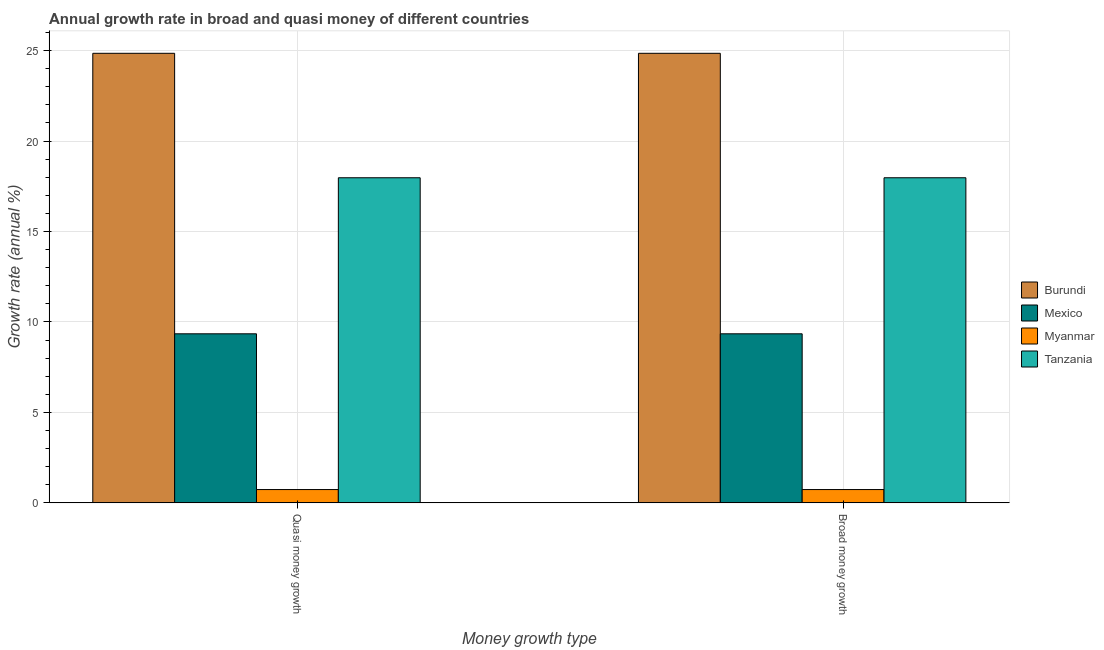How many different coloured bars are there?
Keep it short and to the point. 4. Are the number of bars per tick equal to the number of legend labels?
Keep it short and to the point. Yes. How many bars are there on the 1st tick from the left?
Offer a terse response. 4. What is the label of the 1st group of bars from the left?
Your answer should be compact. Quasi money growth. What is the annual growth rate in broad money in Myanmar?
Your answer should be very brief. 0.73. Across all countries, what is the maximum annual growth rate in quasi money?
Provide a succinct answer. 24.85. Across all countries, what is the minimum annual growth rate in broad money?
Keep it short and to the point. 0.73. In which country was the annual growth rate in quasi money maximum?
Provide a succinct answer. Burundi. In which country was the annual growth rate in quasi money minimum?
Offer a very short reply. Myanmar. What is the total annual growth rate in broad money in the graph?
Your answer should be very brief. 52.89. What is the difference between the annual growth rate in quasi money in Mexico and that in Myanmar?
Offer a terse response. 8.61. What is the difference between the annual growth rate in quasi money in Mexico and the annual growth rate in broad money in Tanzania?
Ensure brevity in your answer.  -8.63. What is the average annual growth rate in broad money per country?
Give a very brief answer. 13.22. What is the difference between the annual growth rate in quasi money and annual growth rate in broad money in Myanmar?
Provide a succinct answer. 0. What is the ratio of the annual growth rate in broad money in Myanmar to that in Tanzania?
Keep it short and to the point. 0.04. What does the 3rd bar from the left in Broad money growth represents?
Provide a short and direct response. Myanmar. What does the 3rd bar from the right in Broad money growth represents?
Keep it short and to the point. Mexico. How many countries are there in the graph?
Provide a short and direct response. 4. What is the difference between two consecutive major ticks on the Y-axis?
Give a very brief answer. 5. Are the values on the major ticks of Y-axis written in scientific E-notation?
Make the answer very short. No. Does the graph contain grids?
Give a very brief answer. Yes. What is the title of the graph?
Your answer should be very brief. Annual growth rate in broad and quasi money of different countries. What is the label or title of the X-axis?
Provide a short and direct response. Money growth type. What is the label or title of the Y-axis?
Provide a succinct answer. Growth rate (annual %). What is the Growth rate (annual %) of Burundi in Quasi money growth?
Offer a very short reply. 24.85. What is the Growth rate (annual %) in Mexico in Quasi money growth?
Offer a very short reply. 9.34. What is the Growth rate (annual %) of Myanmar in Quasi money growth?
Offer a terse response. 0.73. What is the Growth rate (annual %) in Tanzania in Quasi money growth?
Provide a short and direct response. 17.97. What is the Growth rate (annual %) of Burundi in Broad money growth?
Offer a terse response. 24.85. What is the Growth rate (annual %) in Mexico in Broad money growth?
Provide a short and direct response. 9.34. What is the Growth rate (annual %) in Myanmar in Broad money growth?
Keep it short and to the point. 0.73. What is the Growth rate (annual %) of Tanzania in Broad money growth?
Keep it short and to the point. 17.97. Across all Money growth type, what is the maximum Growth rate (annual %) in Burundi?
Your response must be concise. 24.85. Across all Money growth type, what is the maximum Growth rate (annual %) in Mexico?
Keep it short and to the point. 9.34. Across all Money growth type, what is the maximum Growth rate (annual %) in Myanmar?
Keep it short and to the point. 0.73. Across all Money growth type, what is the maximum Growth rate (annual %) in Tanzania?
Provide a short and direct response. 17.97. Across all Money growth type, what is the minimum Growth rate (annual %) in Burundi?
Your answer should be very brief. 24.85. Across all Money growth type, what is the minimum Growth rate (annual %) of Mexico?
Ensure brevity in your answer.  9.34. Across all Money growth type, what is the minimum Growth rate (annual %) of Myanmar?
Offer a terse response. 0.73. Across all Money growth type, what is the minimum Growth rate (annual %) of Tanzania?
Provide a short and direct response. 17.97. What is the total Growth rate (annual %) in Burundi in the graph?
Offer a very short reply. 49.7. What is the total Growth rate (annual %) in Mexico in the graph?
Provide a succinct answer. 18.69. What is the total Growth rate (annual %) in Myanmar in the graph?
Ensure brevity in your answer.  1.47. What is the total Growth rate (annual %) in Tanzania in the graph?
Ensure brevity in your answer.  35.94. What is the difference between the Growth rate (annual %) of Burundi in Quasi money growth and that in Broad money growth?
Offer a terse response. 0. What is the difference between the Growth rate (annual %) in Burundi in Quasi money growth and the Growth rate (annual %) in Mexico in Broad money growth?
Keep it short and to the point. 15.51. What is the difference between the Growth rate (annual %) in Burundi in Quasi money growth and the Growth rate (annual %) in Myanmar in Broad money growth?
Keep it short and to the point. 24.12. What is the difference between the Growth rate (annual %) in Burundi in Quasi money growth and the Growth rate (annual %) in Tanzania in Broad money growth?
Your response must be concise. 6.88. What is the difference between the Growth rate (annual %) in Mexico in Quasi money growth and the Growth rate (annual %) in Myanmar in Broad money growth?
Ensure brevity in your answer.  8.61. What is the difference between the Growth rate (annual %) of Mexico in Quasi money growth and the Growth rate (annual %) of Tanzania in Broad money growth?
Give a very brief answer. -8.63. What is the difference between the Growth rate (annual %) in Myanmar in Quasi money growth and the Growth rate (annual %) in Tanzania in Broad money growth?
Provide a short and direct response. -17.24. What is the average Growth rate (annual %) of Burundi per Money growth type?
Your response must be concise. 24.85. What is the average Growth rate (annual %) of Mexico per Money growth type?
Keep it short and to the point. 9.34. What is the average Growth rate (annual %) of Myanmar per Money growth type?
Your answer should be very brief. 0.73. What is the average Growth rate (annual %) in Tanzania per Money growth type?
Provide a succinct answer. 17.97. What is the difference between the Growth rate (annual %) of Burundi and Growth rate (annual %) of Mexico in Quasi money growth?
Provide a short and direct response. 15.51. What is the difference between the Growth rate (annual %) in Burundi and Growth rate (annual %) in Myanmar in Quasi money growth?
Offer a terse response. 24.12. What is the difference between the Growth rate (annual %) of Burundi and Growth rate (annual %) of Tanzania in Quasi money growth?
Your answer should be very brief. 6.88. What is the difference between the Growth rate (annual %) of Mexico and Growth rate (annual %) of Myanmar in Quasi money growth?
Provide a succinct answer. 8.61. What is the difference between the Growth rate (annual %) in Mexico and Growth rate (annual %) in Tanzania in Quasi money growth?
Offer a terse response. -8.63. What is the difference between the Growth rate (annual %) in Myanmar and Growth rate (annual %) in Tanzania in Quasi money growth?
Provide a succinct answer. -17.24. What is the difference between the Growth rate (annual %) of Burundi and Growth rate (annual %) of Mexico in Broad money growth?
Make the answer very short. 15.51. What is the difference between the Growth rate (annual %) of Burundi and Growth rate (annual %) of Myanmar in Broad money growth?
Offer a very short reply. 24.12. What is the difference between the Growth rate (annual %) in Burundi and Growth rate (annual %) in Tanzania in Broad money growth?
Your answer should be compact. 6.88. What is the difference between the Growth rate (annual %) in Mexico and Growth rate (annual %) in Myanmar in Broad money growth?
Ensure brevity in your answer.  8.61. What is the difference between the Growth rate (annual %) of Mexico and Growth rate (annual %) of Tanzania in Broad money growth?
Offer a terse response. -8.63. What is the difference between the Growth rate (annual %) in Myanmar and Growth rate (annual %) in Tanzania in Broad money growth?
Offer a very short reply. -17.24. What is the difference between the highest and the second highest Growth rate (annual %) in Burundi?
Give a very brief answer. 0. What is the difference between the highest and the second highest Growth rate (annual %) in Mexico?
Give a very brief answer. 0. What is the difference between the highest and the lowest Growth rate (annual %) of Burundi?
Give a very brief answer. 0. What is the difference between the highest and the lowest Growth rate (annual %) of Mexico?
Offer a very short reply. 0. 